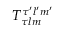<formula> <loc_0><loc_0><loc_500><loc_500>T _ { \tau l m } ^ { \tau ^ { \prime } l ^ { \prime } m ^ { \prime } }</formula> 